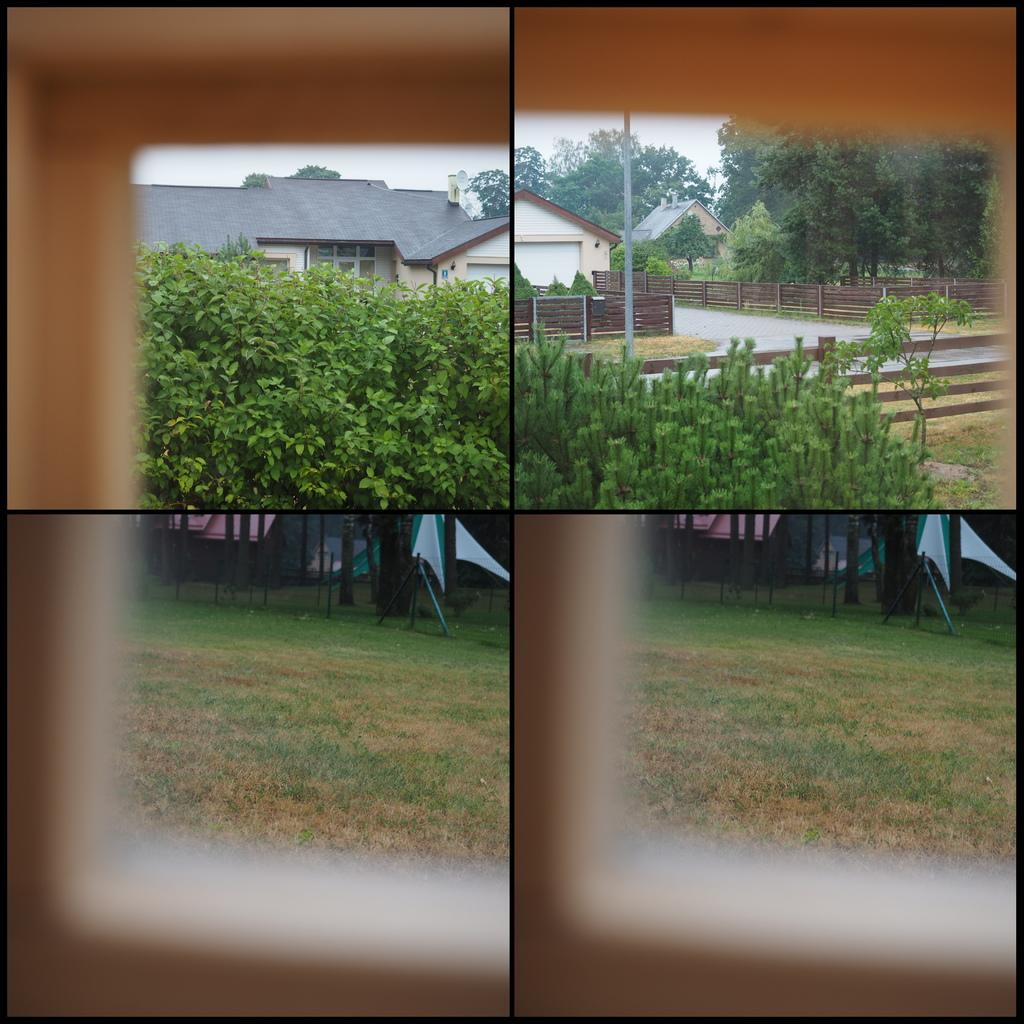What type of artwork is the image? The image is a collage. What type of natural elements are present in the image? There are plants and grass on the ground in the image. What type of structure is visible in the image? There is a house in the image. What type of barrier is present in the image? There is a fence in the image. What type of symbolic objects are present in the image? There are flags in the image. How many cubs are playing with the spade in the image? There are no cubs or spades present in the image. What type of animal is grazing in the grass in the image? There are no animals visible in the image; it only features plants, grass, a house, a fence, and flags. 